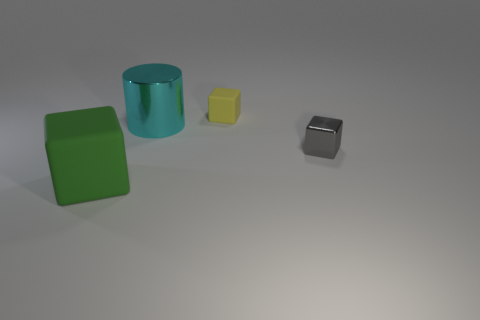Are there any other things that are the same shape as the cyan object?
Provide a succinct answer. No. What shape is the metallic thing that is to the left of the rubber object that is behind the large object to the left of the big cyan cylinder?
Your response must be concise. Cylinder. Is the shape of the big object that is on the right side of the big green block the same as the small thing that is in front of the yellow rubber thing?
Give a very brief answer. No. What number of other things are the same material as the big green block?
Your response must be concise. 1. What is the shape of the small gray thing that is the same material as the cyan cylinder?
Your response must be concise. Cube. Is the size of the yellow thing the same as the gray object?
Your answer should be compact. Yes. There is a rubber thing behind the cube that is left of the cyan cylinder; how big is it?
Ensure brevity in your answer.  Small. How many balls are red metallic things or small gray objects?
Offer a very short reply. 0. Does the cyan metallic cylinder have the same size as the rubber object to the right of the big green thing?
Give a very brief answer. No. Is the number of large shiny things on the right side of the big metallic object greater than the number of large yellow balls?
Make the answer very short. No. 